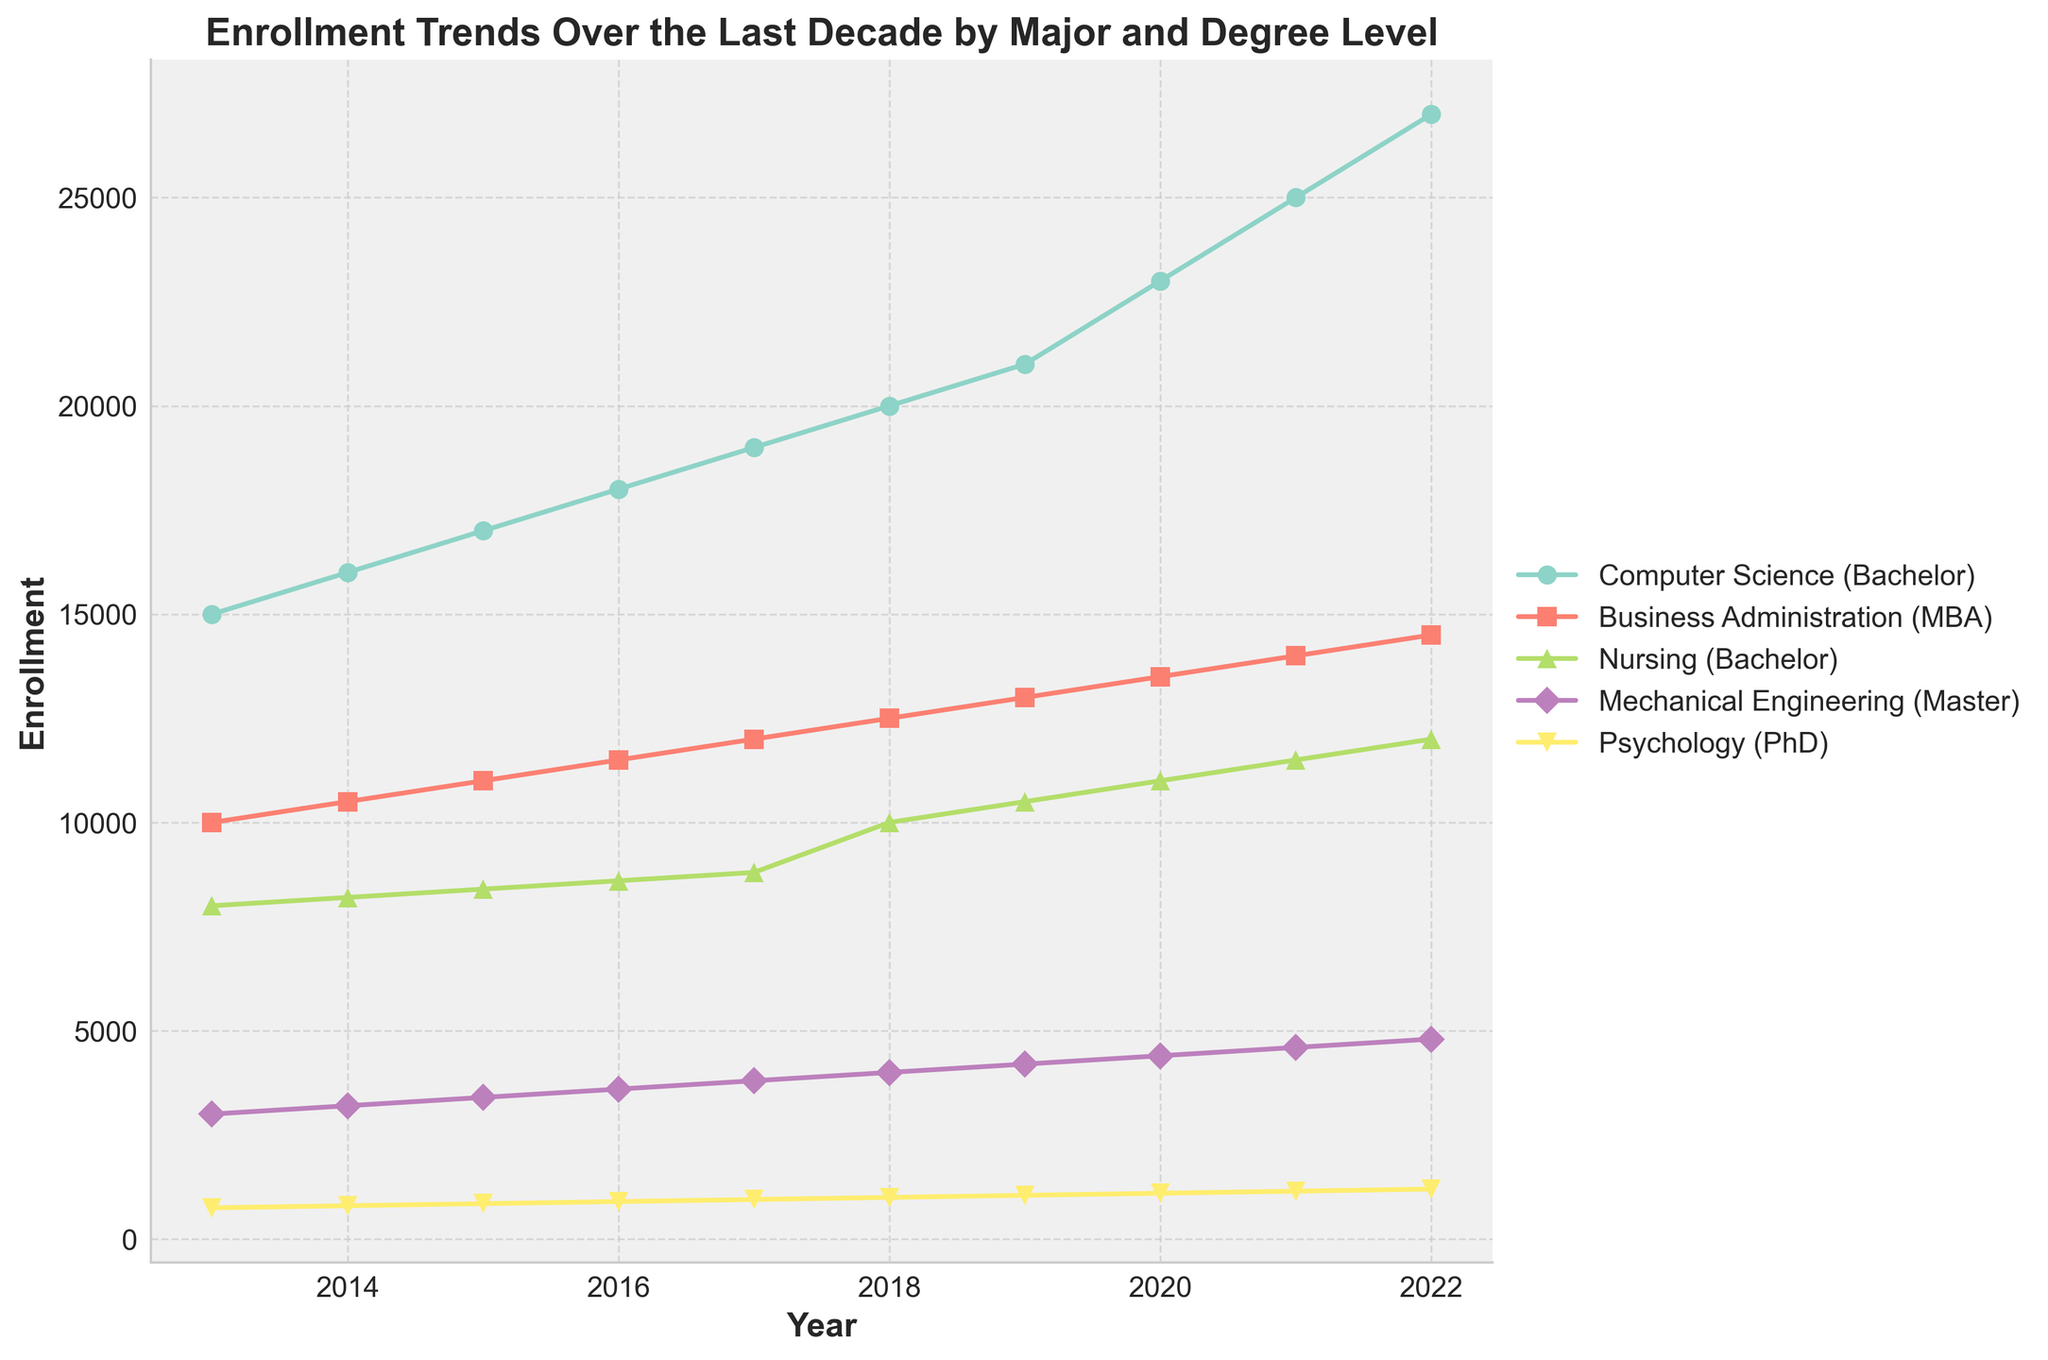What is the title of the plot? The title of the plot is clearly written at the top of the figure in a large, bold font. It reads "Enrollment Trends Over the Last Decade by Major and Degree Level".
Answer: Enrollment Trends Over the Last Decade by Major and Degree Level How many majors are displayed in the plot? Each major is represented by a different line in the plot. Since there are five lines, there are five majors displayed in the plot.
Answer: Five Which major had the highest enrollment in the final year displayed? By examining the trends of each line up to 2022, the line representing Computer Science (Bachelor) reaches the highest value on the y-axis, indicating it had the highest enrollment.
Answer: Computer Science (Bachelor) What is the general trend in Computer Science enrollment over the decade? Observing the line for Computer Science (Bachelor) from 2013 to 2022, we see a continuous upward trajectory, indicating an increasing enrollment trend throughout the decade.
Answer: Increasing Compare the MBA enrollment to Mechanical Engineering (Master) enrollment in 2020. Which is higher and by how much? Look at the data points of each major for the year 2020. The MBA enrollment is 13,500 and Mechanical Engineering (Master) enrollment is 4,400. The difference is 13,500 - 4,400.
Answer: MBA is higher by 9,100 Which major had a steady increase in enrollment without any year-to-year decrease? By examining each line in the plot, we see that Computer Science (Bachelor), Business Administration (MBA), and Psychology (PhD) all show steady increases without any dips.
Answer: Computer Science (Bachelor), Business Administration (MBA), Psychology (PhD) What is the average enrollment in Nursing (Bachelor) throughout the decade? The enrollment values for Nursing (Bachelor) are 8000, 8200, 8400, 8600, 8800, 10000, 10500, 11000, 11500, and 12000. Summing these values: 97,000 and dividing by the number of years (10) gives the average.
Answer: 9700 Did the enrollment for Psychology (PhD) experience a steeper increase initially or in the latter half of the decade? By comparing the slope of the Psychology (PhD) line from 2013-2017 and 2018-2022, it is evident that the increase is steeper in the second half (2018-2022).
Answer: Latter half Which major had the smallest enrollment at the start of the decade? By looking at the data points for each major in 2013, Psychology (PhD) had the smallest enrollment at 750.
Answer: Psychology (PhD) What is the total increase in enrollment for Business Administration (MBA) from the start to the end of the decade? The enrollment for Business Administration (MBA) in 2013 was 10,000 and in 2022 it was 14,500. The difference between these values is the total increase: 14,500 - 10,000.
Answer: 4,500 